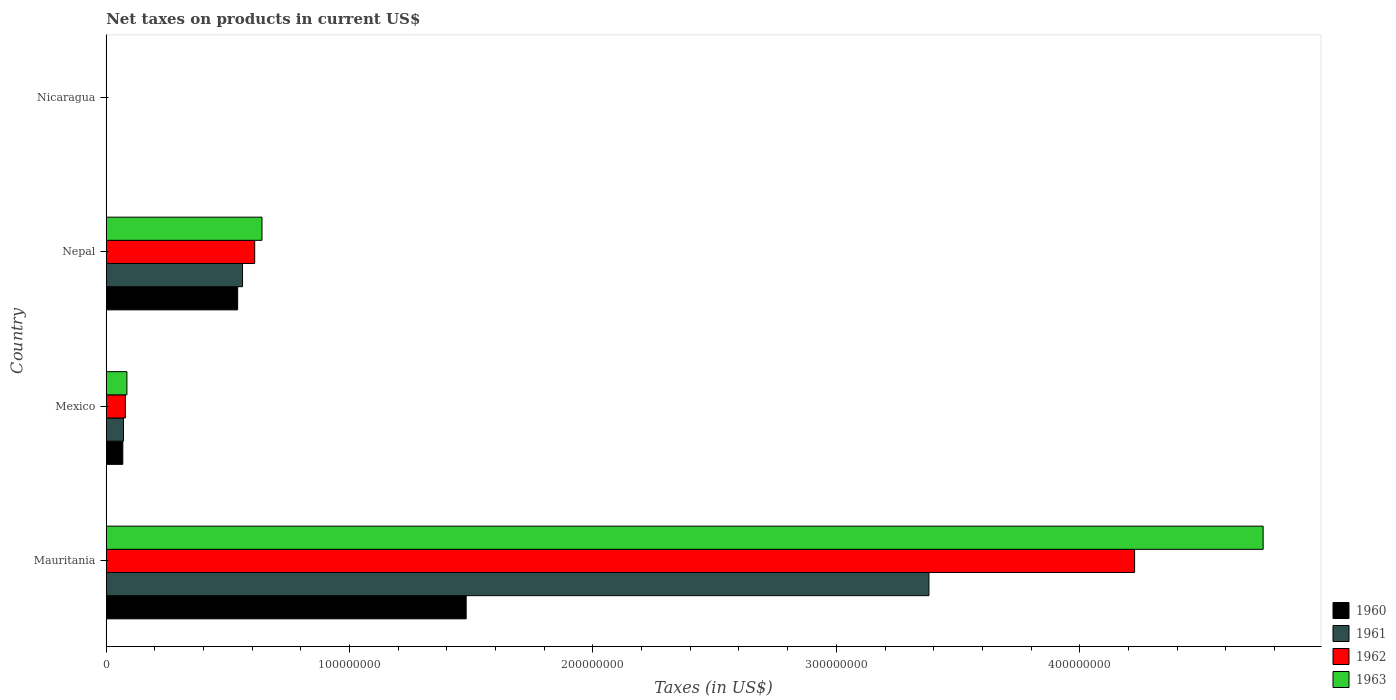How many different coloured bars are there?
Offer a very short reply. 4. How many groups of bars are there?
Keep it short and to the point. 4. What is the label of the 4th group of bars from the top?
Ensure brevity in your answer.  Mauritania. What is the net taxes on products in 1960 in Nepal?
Your answer should be compact. 5.40e+07. Across all countries, what is the maximum net taxes on products in 1960?
Make the answer very short. 1.48e+08. Across all countries, what is the minimum net taxes on products in 1960?
Provide a succinct answer. 0.03. In which country was the net taxes on products in 1963 maximum?
Your answer should be very brief. Mauritania. In which country was the net taxes on products in 1960 minimum?
Your response must be concise. Nicaragua. What is the total net taxes on products in 1961 in the graph?
Provide a succinct answer. 4.01e+08. What is the difference between the net taxes on products in 1960 in Mexico and that in Nicaragua?
Make the answer very short. 6.81e+06. What is the difference between the net taxes on products in 1963 in Mauritania and the net taxes on products in 1962 in Nepal?
Provide a short and direct response. 4.14e+08. What is the average net taxes on products in 1961 per country?
Give a very brief answer. 1.00e+08. What is the difference between the net taxes on products in 1961 and net taxes on products in 1960 in Nicaragua?
Offer a very short reply. 0. In how many countries, is the net taxes on products in 1960 greater than 260000000 US$?
Your answer should be very brief. 0. What is the ratio of the net taxes on products in 1960 in Nepal to that in Nicaragua?
Keep it short and to the point. 1.81e+09. What is the difference between the highest and the second highest net taxes on products in 1961?
Offer a very short reply. 2.82e+08. What is the difference between the highest and the lowest net taxes on products in 1963?
Your response must be concise. 4.75e+08. In how many countries, is the net taxes on products in 1963 greater than the average net taxes on products in 1963 taken over all countries?
Provide a succinct answer. 1. Is it the case that in every country, the sum of the net taxes on products in 1962 and net taxes on products in 1963 is greater than the sum of net taxes on products in 1960 and net taxes on products in 1961?
Offer a very short reply. No. What does the 3rd bar from the top in Nicaragua represents?
Provide a succinct answer. 1961. Is it the case that in every country, the sum of the net taxes on products in 1960 and net taxes on products in 1962 is greater than the net taxes on products in 1963?
Ensure brevity in your answer.  Yes. How many bars are there?
Provide a short and direct response. 16. Are all the bars in the graph horizontal?
Make the answer very short. Yes. How many countries are there in the graph?
Your answer should be very brief. 4. What is the difference between two consecutive major ticks on the X-axis?
Offer a very short reply. 1.00e+08. Are the values on the major ticks of X-axis written in scientific E-notation?
Offer a terse response. No. Does the graph contain any zero values?
Make the answer very short. No. How are the legend labels stacked?
Your answer should be very brief. Vertical. What is the title of the graph?
Your response must be concise. Net taxes on products in current US$. What is the label or title of the X-axis?
Your answer should be compact. Taxes (in US$). What is the label or title of the Y-axis?
Ensure brevity in your answer.  Country. What is the Taxes (in US$) in 1960 in Mauritania?
Offer a terse response. 1.48e+08. What is the Taxes (in US$) in 1961 in Mauritania?
Provide a short and direct response. 3.38e+08. What is the Taxes (in US$) in 1962 in Mauritania?
Ensure brevity in your answer.  4.23e+08. What is the Taxes (in US$) in 1963 in Mauritania?
Offer a very short reply. 4.75e+08. What is the Taxes (in US$) in 1960 in Mexico?
Provide a short and direct response. 6.81e+06. What is the Taxes (in US$) in 1961 in Mexico?
Offer a terse response. 7.08e+06. What is the Taxes (in US$) in 1962 in Mexico?
Give a very brief answer. 7.85e+06. What is the Taxes (in US$) of 1963 in Mexico?
Ensure brevity in your answer.  8.49e+06. What is the Taxes (in US$) in 1960 in Nepal?
Make the answer very short. 5.40e+07. What is the Taxes (in US$) in 1961 in Nepal?
Offer a very short reply. 5.60e+07. What is the Taxes (in US$) in 1962 in Nepal?
Your answer should be very brief. 6.10e+07. What is the Taxes (in US$) of 1963 in Nepal?
Provide a succinct answer. 6.40e+07. What is the Taxes (in US$) of 1960 in Nicaragua?
Your answer should be compact. 0.03. What is the Taxes (in US$) in 1961 in Nicaragua?
Keep it short and to the point. 0.03. What is the Taxes (in US$) of 1962 in Nicaragua?
Your answer should be very brief. 0.04. What is the Taxes (in US$) in 1963 in Nicaragua?
Offer a very short reply. 0.04. Across all countries, what is the maximum Taxes (in US$) in 1960?
Keep it short and to the point. 1.48e+08. Across all countries, what is the maximum Taxes (in US$) of 1961?
Keep it short and to the point. 3.38e+08. Across all countries, what is the maximum Taxes (in US$) of 1962?
Make the answer very short. 4.23e+08. Across all countries, what is the maximum Taxes (in US$) of 1963?
Provide a short and direct response. 4.75e+08. Across all countries, what is the minimum Taxes (in US$) of 1960?
Provide a short and direct response. 0.03. Across all countries, what is the minimum Taxes (in US$) in 1961?
Make the answer very short. 0.03. Across all countries, what is the minimum Taxes (in US$) in 1962?
Ensure brevity in your answer.  0.04. Across all countries, what is the minimum Taxes (in US$) in 1963?
Ensure brevity in your answer.  0.04. What is the total Taxes (in US$) in 1960 in the graph?
Ensure brevity in your answer.  2.09e+08. What is the total Taxes (in US$) of 1961 in the graph?
Provide a succinct answer. 4.01e+08. What is the total Taxes (in US$) in 1962 in the graph?
Provide a succinct answer. 4.91e+08. What is the total Taxes (in US$) in 1963 in the graph?
Your answer should be compact. 5.48e+08. What is the difference between the Taxes (in US$) in 1960 in Mauritania and that in Mexico?
Your answer should be very brief. 1.41e+08. What is the difference between the Taxes (in US$) in 1961 in Mauritania and that in Mexico?
Give a very brief answer. 3.31e+08. What is the difference between the Taxes (in US$) in 1962 in Mauritania and that in Mexico?
Provide a succinct answer. 4.15e+08. What is the difference between the Taxes (in US$) of 1963 in Mauritania and that in Mexico?
Offer a very short reply. 4.67e+08. What is the difference between the Taxes (in US$) of 1960 in Mauritania and that in Nepal?
Your answer should be very brief. 9.39e+07. What is the difference between the Taxes (in US$) in 1961 in Mauritania and that in Nepal?
Your answer should be compact. 2.82e+08. What is the difference between the Taxes (in US$) in 1962 in Mauritania and that in Nepal?
Your response must be concise. 3.62e+08. What is the difference between the Taxes (in US$) in 1963 in Mauritania and that in Nepal?
Offer a terse response. 4.11e+08. What is the difference between the Taxes (in US$) in 1960 in Mauritania and that in Nicaragua?
Provide a short and direct response. 1.48e+08. What is the difference between the Taxes (in US$) in 1961 in Mauritania and that in Nicaragua?
Keep it short and to the point. 3.38e+08. What is the difference between the Taxes (in US$) in 1962 in Mauritania and that in Nicaragua?
Keep it short and to the point. 4.23e+08. What is the difference between the Taxes (in US$) in 1963 in Mauritania and that in Nicaragua?
Keep it short and to the point. 4.75e+08. What is the difference between the Taxes (in US$) of 1960 in Mexico and that in Nepal?
Give a very brief answer. -4.72e+07. What is the difference between the Taxes (in US$) of 1961 in Mexico and that in Nepal?
Provide a succinct answer. -4.89e+07. What is the difference between the Taxes (in US$) in 1962 in Mexico and that in Nepal?
Your answer should be very brief. -5.32e+07. What is the difference between the Taxes (in US$) in 1963 in Mexico and that in Nepal?
Your response must be concise. -5.55e+07. What is the difference between the Taxes (in US$) in 1960 in Mexico and that in Nicaragua?
Offer a very short reply. 6.81e+06. What is the difference between the Taxes (in US$) in 1961 in Mexico and that in Nicaragua?
Your answer should be compact. 7.08e+06. What is the difference between the Taxes (in US$) in 1962 in Mexico and that in Nicaragua?
Offer a very short reply. 7.85e+06. What is the difference between the Taxes (in US$) of 1963 in Mexico and that in Nicaragua?
Provide a succinct answer. 8.49e+06. What is the difference between the Taxes (in US$) of 1960 in Nepal and that in Nicaragua?
Make the answer very short. 5.40e+07. What is the difference between the Taxes (in US$) of 1961 in Nepal and that in Nicaragua?
Keep it short and to the point. 5.60e+07. What is the difference between the Taxes (in US$) of 1962 in Nepal and that in Nicaragua?
Provide a short and direct response. 6.10e+07. What is the difference between the Taxes (in US$) of 1963 in Nepal and that in Nicaragua?
Make the answer very short. 6.40e+07. What is the difference between the Taxes (in US$) of 1960 in Mauritania and the Taxes (in US$) of 1961 in Mexico?
Your answer should be very brief. 1.41e+08. What is the difference between the Taxes (in US$) of 1960 in Mauritania and the Taxes (in US$) of 1962 in Mexico?
Your answer should be very brief. 1.40e+08. What is the difference between the Taxes (in US$) in 1960 in Mauritania and the Taxes (in US$) in 1963 in Mexico?
Make the answer very short. 1.39e+08. What is the difference between the Taxes (in US$) of 1961 in Mauritania and the Taxes (in US$) of 1962 in Mexico?
Offer a terse response. 3.30e+08. What is the difference between the Taxes (in US$) of 1961 in Mauritania and the Taxes (in US$) of 1963 in Mexico?
Ensure brevity in your answer.  3.30e+08. What is the difference between the Taxes (in US$) in 1962 in Mauritania and the Taxes (in US$) in 1963 in Mexico?
Keep it short and to the point. 4.14e+08. What is the difference between the Taxes (in US$) of 1960 in Mauritania and the Taxes (in US$) of 1961 in Nepal?
Your answer should be very brief. 9.19e+07. What is the difference between the Taxes (in US$) of 1960 in Mauritania and the Taxes (in US$) of 1962 in Nepal?
Your answer should be very brief. 8.69e+07. What is the difference between the Taxes (in US$) in 1960 in Mauritania and the Taxes (in US$) in 1963 in Nepal?
Your response must be concise. 8.39e+07. What is the difference between the Taxes (in US$) in 1961 in Mauritania and the Taxes (in US$) in 1962 in Nepal?
Offer a very short reply. 2.77e+08. What is the difference between the Taxes (in US$) of 1961 in Mauritania and the Taxes (in US$) of 1963 in Nepal?
Keep it short and to the point. 2.74e+08. What is the difference between the Taxes (in US$) of 1962 in Mauritania and the Taxes (in US$) of 1963 in Nepal?
Offer a very short reply. 3.59e+08. What is the difference between the Taxes (in US$) in 1960 in Mauritania and the Taxes (in US$) in 1961 in Nicaragua?
Your answer should be compact. 1.48e+08. What is the difference between the Taxes (in US$) in 1960 in Mauritania and the Taxes (in US$) in 1962 in Nicaragua?
Make the answer very short. 1.48e+08. What is the difference between the Taxes (in US$) in 1960 in Mauritania and the Taxes (in US$) in 1963 in Nicaragua?
Give a very brief answer. 1.48e+08. What is the difference between the Taxes (in US$) of 1961 in Mauritania and the Taxes (in US$) of 1962 in Nicaragua?
Your answer should be compact. 3.38e+08. What is the difference between the Taxes (in US$) in 1961 in Mauritania and the Taxes (in US$) in 1963 in Nicaragua?
Provide a short and direct response. 3.38e+08. What is the difference between the Taxes (in US$) of 1962 in Mauritania and the Taxes (in US$) of 1963 in Nicaragua?
Keep it short and to the point. 4.23e+08. What is the difference between the Taxes (in US$) in 1960 in Mexico and the Taxes (in US$) in 1961 in Nepal?
Ensure brevity in your answer.  -4.92e+07. What is the difference between the Taxes (in US$) of 1960 in Mexico and the Taxes (in US$) of 1962 in Nepal?
Keep it short and to the point. -5.42e+07. What is the difference between the Taxes (in US$) of 1960 in Mexico and the Taxes (in US$) of 1963 in Nepal?
Keep it short and to the point. -5.72e+07. What is the difference between the Taxes (in US$) in 1961 in Mexico and the Taxes (in US$) in 1962 in Nepal?
Provide a short and direct response. -5.39e+07. What is the difference between the Taxes (in US$) in 1961 in Mexico and the Taxes (in US$) in 1963 in Nepal?
Offer a terse response. -5.69e+07. What is the difference between the Taxes (in US$) of 1962 in Mexico and the Taxes (in US$) of 1963 in Nepal?
Give a very brief answer. -5.62e+07. What is the difference between the Taxes (in US$) in 1960 in Mexico and the Taxes (in US$) in 1961 in Nicaragua?
Your response must be concise. 6.81e+06. What is the difference between the Taxes (in US$) of 1960 in Mexico and the Taxes (in US$) of 1962 in Nicaragua?
Provide a short and direct response. 6.81e+06. What is the difference between the Taxes (in US$) in 1960 in Mexico and the Taxes (in US$) in 1963 in Nicaragua?
Keep it short and to the point. 6.81e+06. What is the difference between the Taxes (in US$) of 1961 in Mexico and the Taxes (in US$) of 1962 in Nicaragua?
Keep it short and to the point. 7.08e+06. What is the difference between the Taxes (in US$) in 1961 in Mexico and the Taxes (in US$) in 1963 in Nicaragua?
Your answer should be very brief. 7.08e+06. What is the difference between the Taxes (in US$) in 1962 in Mexico and the Taxes (in US$) in 1963 in Nicaragua?
Give a very brief answer. 7.85e+06. What is the difference between the Taxes (in US$) in 1960 in Nepal and the Taxes (in US$) in 1961 in Nicaragua?
Your answer should be very brief. 5.40e+07. What is the difference between the Taxes (in US$) of 1960 in Nepal and the Taxes (in US$) of 1962 in Nicaragua?
Your response must be concise. 5.40e+07. What is the difference between the Taxes (in US$) of 1960 in Nepal and the Taxes (in US$) of 1963 in Nicaragua?
Your answer should be compact. 5.40e+07. What is the difference between the Taxes (in US$) in 1961 in Nepal and the Taxes (in US$) in 1962 in Nicaragua?
Offer a very short reply. 5.60e+07. What is the difference between the Taxes (in US$) in 1961 in Nepal and the Taxes (in US$) in 1963 in Nicaragua?
Make the answer very short. 5.60e+07. What is the difference between the Taxes (in US$) of 1962 in Nepal and the Taxes (in US$) of 1963 in Nicaragua?
Make the answer very short. 6.10e+07. What is the average Taxes (in US$) in 1960 per country?
Ensure brevity in your answer.  5.22e+07. What is the average Taxes (in US$) in 1961 per country?
Give a very brief answer. 1.00e+08. What is the average Taxes (in US$) of 1962 per country?
Give a very brief answer. 1.23e+08. What is the average Taxes (in US$) of 1963 per country?
Provide a short and direct response. 1.37e+08. What is the difference between the Taxes (in US$) of 1960 and Taxes (in US$) of 1961 in Mauritania?
Make the answer very short. -1.90e+08. What is the difference between the Taxes (in US$) of 1960 and Taxes (in US$) of 1962 in Mauritania?
Provide a short and direct response. -2.75e+08. What is the difference between the Taxes (in US$) of 1960 and Taxes (in US$) of 1963 in Mauritania?
Ensure brevity in your answer.  -3.27e+08. What is the difference between the Taxes (in US$) in 1961 and Taxes (in US$) in 1962 in Mauritania?
Provide a succinct answer. -8.45e+07. What is the difference between the Taxes (in US$) of 1961 and Taxes (in US$) of 1963 in Mauritania?
Ensure brevity in your answer.  -1.37e+08. What is the difference between the Taxes (in US$) of 1962 and Taxes (in US$) of 1963 in Mauritania?
Offer a very short reply. -5.28e+07. What is the difference between the Taxes (in US$) in 1960 and Taxes (in US$) in 1961 in Mexico?
Your answer should be very brief. -2.73e+05. What is the difference between the Taxes (in US$) of 1960 and Taxes (in US$) of 1962 in Mexico?
Keep it short and to the point. -1.04e+06. What is the difference between the Taxes (in US$) of 1960 and Taxes (in US$) of 1963 in Mexico?
Ensure brevity in your answer.  -1.69e+06. What is the difference between the Taxes (in US$) of 1961 and Taxes (in US$) of 1962 in Mexico?
Provide a short and direct response. -7.69e+05. What is the difference between the Taxes (in US$) of 1961 and Taxes (in US$) of 1963 in Mexico?
Offer a terse response. -1.41e+06. What is the difference between the Taxes (in US$) of 1962 and Taxes (in US$) of 1963 in Mexico?
Your response must be concise. -6.43e+05. What is the difference between the Taxes (in US$) in 1960 and Taxes (in US$) in 1962 in Nepal?
Provide a succinct answer. -7.00e+06. What is the difference between the Taxes (in US$) in 1960 and Taxes (in US$) in 1963 in Nepal?
Ensure brevity in your answer.  -1.00e+07. What is the difference between the Taxes (in US$) of 1961 and Taxes (in US$) of 1962 in Nepal?
Provide a short and direct response. -5.00e+06. What is the difference between the Taxes (in US$) of 1961 and Taxes (in US$) of 1963 in Nepal?
Your response must be concise. -8.00e+06. What is the difference between the Taxes (in US$) of 1960 and Taxes (in US$) of 1961 in Nicaragua?
Your response must be concise. -0. What is the difference between the Taxes (in US$) of 1960 and Taxes (in US$) of 1962 in Nicaragua?
Your answer should be compact. -0.01. What is the difference between the Taxes (in US$) of 1960 and Taxes (in US$) of 1963 in Nicaragua?
Keep it short and to the point. -0.01. What is the difference between the Taxes (in US$) of 1961 and Taxes (in US$) of 1962 in Nicaragua?
Provide a short and direct response. -0. What is the difference between the Taxes (in US$) in 1961 and Taxes (in US$) in 1963 in Nicaragua?
Offer a very short reply. -0.01. What is the difference between the Taxes (in US$) in 1962 and Taxes (in US$) in 1963 in Nicaragua?
Your response must be concise. -0.01. What is the ratio of the Taxes (in US$) in 1960 in Mauritania to that in Mexico?
Ensure brevity in your answer.  21.73. What is the ratio of the Taxes (in US$) of 1961 in Mauritania to that in Mexico?
Provide a succinct answer. 47.75. What is the ratio of the Taxes (in US$) in 1962 in Mauritania to that in Mexico?
Provide a short and direct response. 53.84. What is the ratio of the Taxes (in US$) of 1963 in Mauritania to that in Mexico?
Provide a succinct answer. 55.98. What is the ratio of the Taxes (in US$) in 1960 in Mauritania to that in Nepal?
Your response must be concise. 2.74. What is the ratio of the Taxes (in US$) of 1961 in Mauritania to that in Nepal?
Make the answer very short. 6.04. What is the ratio of the Taxes (in US$) of 1962 in Mauritania to that in Nepal?
Offer a terse response. 6.93. What is the ratio of the Taxes (in US$) of 1963 in Mauritania to that in Nepal?
Your answer should be compact. 7.43. What is the ratio of the Taxes (in US$) of 1960 in Mauritania to that in Nicaragua?
Make the answer very short. 4.97e+09. What is the ratio of the Taxes (in US$) of 1961 in Mauritania to that in Nicaragua?
Offer a terse response. 1.09e+1. What is the ratio of the Taxes (in US$) in 1962 in Mauritania to that in Nicaragua?
Your response must be concise. 1.20e+1. What is the ratio of the Taxes (in US$) in 1963 in Mauritania to that in Nicaragua?
Provide a succinct answer. 1.14e+1. What is the ratio of the Taxes (in US$) in 1960 in Mexico to that in Nepal?
Your answer should be very brief. 0.13. What is the ratio of the Taxes (in US$) in 1961 in Mexico to that in Nepal?
Provide a short and direct response. 0.13. What is the ratio of the Taxes (in US$) of 1962 in Mexico to that in Nepal?
Offer a terse response. 0.13. What is the ratio of the Taxes (in US$) in 1963 in Mexico to that in Nepal?
Offer a very short reply. 0.13. What is the ratio of the Taxes (in US$) in 1960 in Mexico to that in Nicaragua?
Keep it short and to the point. 2.29e+08. What is the ratio of the Taxes (in US$) of 1961 in Mexico to that in Nicaragua?
Offer a very short reply. 2.27e+08. What is the ratio of the Taxes (in US$) in 1962 in Mexico to that in Nicaragua?
Provide a short and direct response. 2.22e+08. What is the ratio of the Taxes (in US$) in 1963 in Mexico to that in Nicaragua?
Make the answer very short. 2.04e+08. What is the ratio of the Taxes (in US$) of 1960 in Nepal to that in Nicaragua?
Give a very brief answer. 1.81e+09. What is the ratio of the Taxes (in US$) of 1961 in Nepal to that in Nicaragua?
Give a very brief answer. 1.80e+09. What is the ratio of the Taxes (in US$) in 1962 in Nepal to that in Nicaragua?
Keep it short and to the point. 1.73e+09. What is the ratio of the Taxes (in US$) in 1963 in Nepal to that in Nicaragua?
Your response must be concise. 1.54e+09. What is the difference between the highest and the second highest Taxes (in US$) in 1960?
Your response must be concise. 9.39e+07. What is the difference between the highest and the second highest Taxes (in US$) of 1961?
Your answer should be compact. 2.82e+08. What is the difference between the highest and the second highest Taxes (in US$) in 1962?
Provide a short and direct response. 3.62e+08. What is the difference between the highest and the second highest Taxes (in US$) in 1963?
Give a very brief answer. 4.11e+08. What is the difference between the highest and the lowest Taxes (in US$) of 1960?
Your answer should be compact. 1.48e+08. What is the difference between the highest and the lowest Taxes (in US$) in 1961?
Provide a succinct answer. 3.38e+08. What is the difference between the highest and the lowest Taxes (in US$) in 1962?
Make the answer very short. 4.23e+08. What is the difference between the highest and the lowest Taxes (in US$) of 1963?
Make the answer very short. 4.75e+08. 